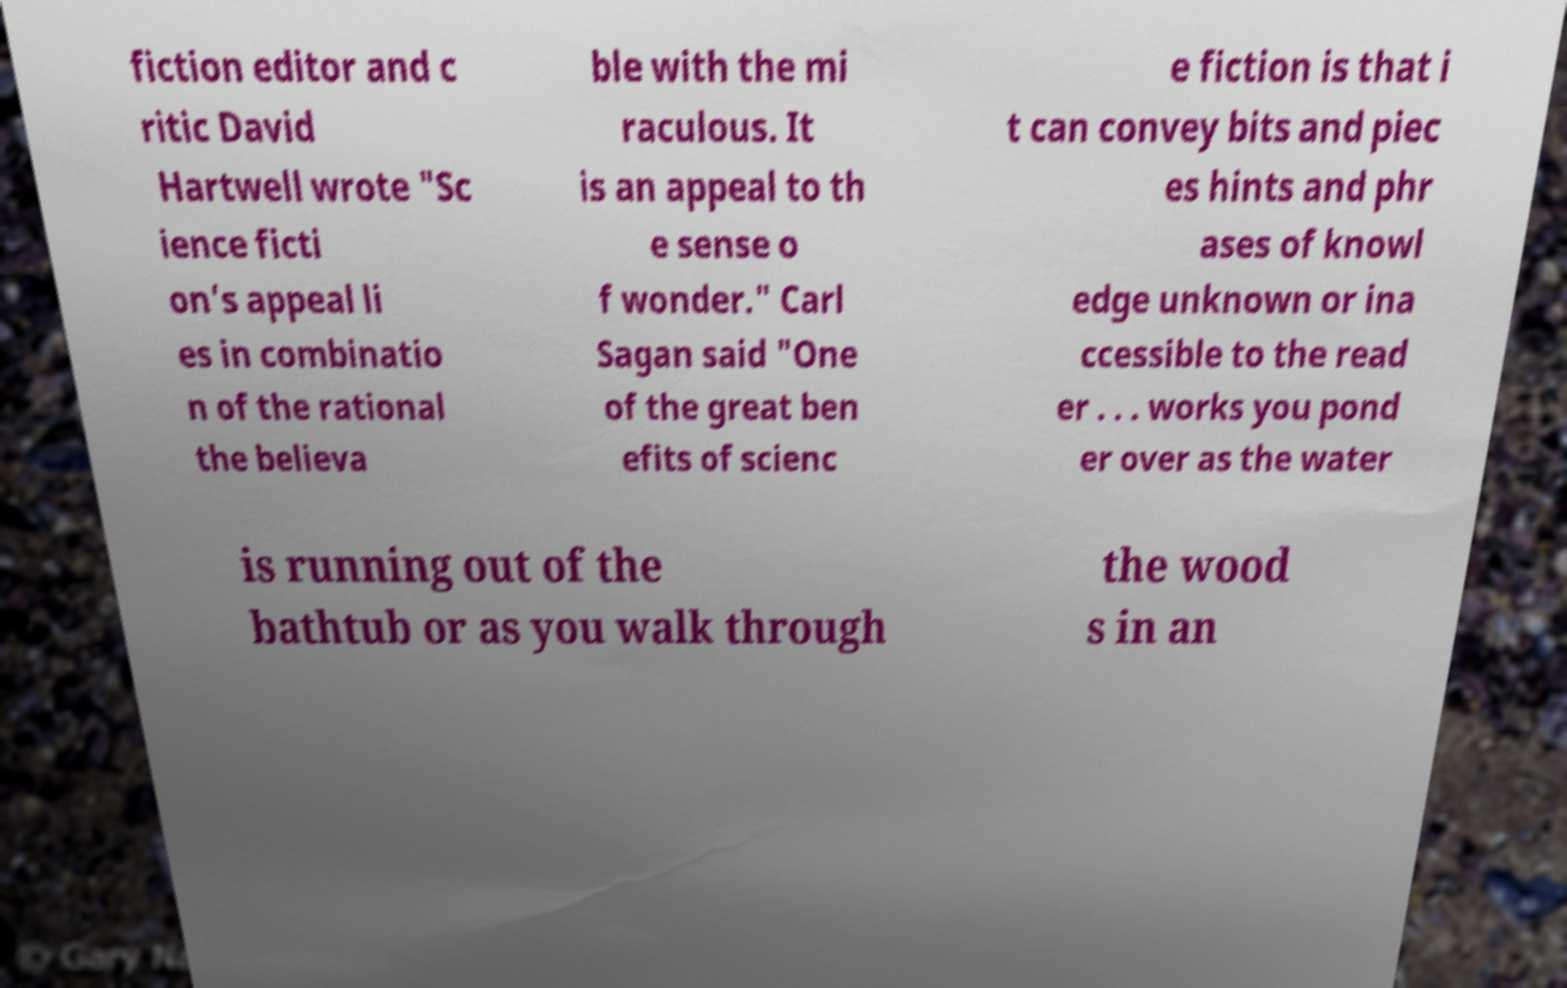Could you extract and type out the text from this image? fiction editor and c ritic David Hartwell wrote "Sc ience ficti on’s appeal li es in combinatio n of the rational the believa ble with the mi raculous. It is an appeal to th e sense o f wonder." Carl Sagan said "One of the great ben efits of scienc e fiction is that i t can convey bits and piec es hints and phr ases of knowl edge unknown or ina ccessible to the read er . . . works you pond er over as the water is running out of the bathtub or as you walk through the wood s in an 